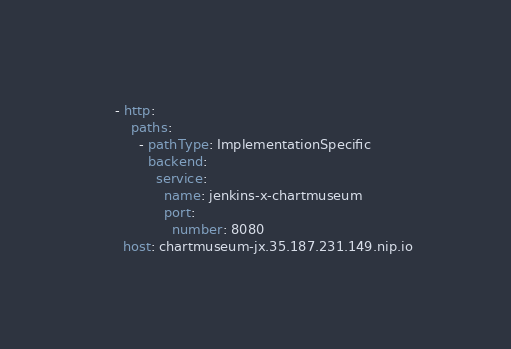<code> <loc_0><loc_0><loc_500><loc_500><_YAML_>    - http:
        paths:
          - pathType: ImplementationSpecific
            backend:
              service:
                name: jenkins-x-chartmuseum
                port:
                  number: 8080
      host: chartmuseum-jx.35.187.231.149.nip.io
</code> 